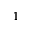<formula> <loc_0><loc_0><loc_500><loc_500>1</formula> 